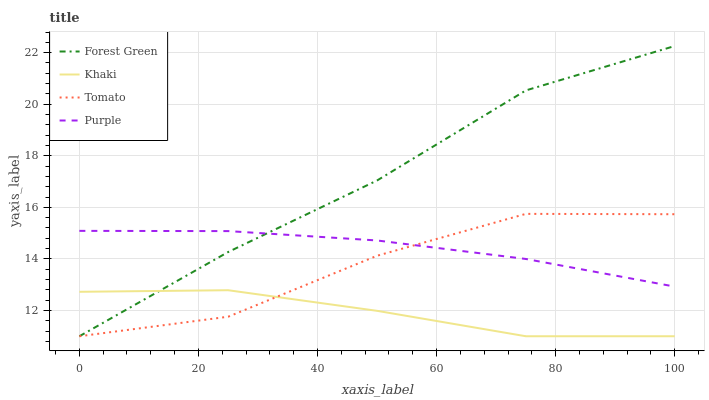Does Khaki have the minimum area under the curve?
Answer yes or no. Yes. Does Forest Green have the maximum area under the curve?
Answer yes or no. Yes. Does Purple have the minimum area under the curve?
Answer yes or no. No. Does Purple have the maximum area under the curve?
Answer yes or no. No. Is Purple the smoothest?
Answer yes or no. Yes. Is Tomato the roughest?
Answer yes or no. Yes. Is Forest Green the smoothest?
Answer yes or no. No. Is Forest Green the roughest?
Answer yes or no. No. Does Tomato have the lowest value?
Answer yes or no. Yes. Does Purple have the lowest value?
Answer yes or no. No. Does Forest Green have the highest value?
Answer yes or no. Yes. Does Purple have the highest value?
Answer yes or no. No. Is Khaki less than Purple?
Answer yes or no. Yes. Is Purple greater than Khaki?
Answer yes or no. Yes. Does Tomato intersect Purple?
Answer yes or no. Yes. Is Tomato less than Purple?
Answer yes or no. No. Is Tomato greater than Purple?
Answer yes or no. No. Does Khaki intersect Purple?
Answer yes or no. No. 